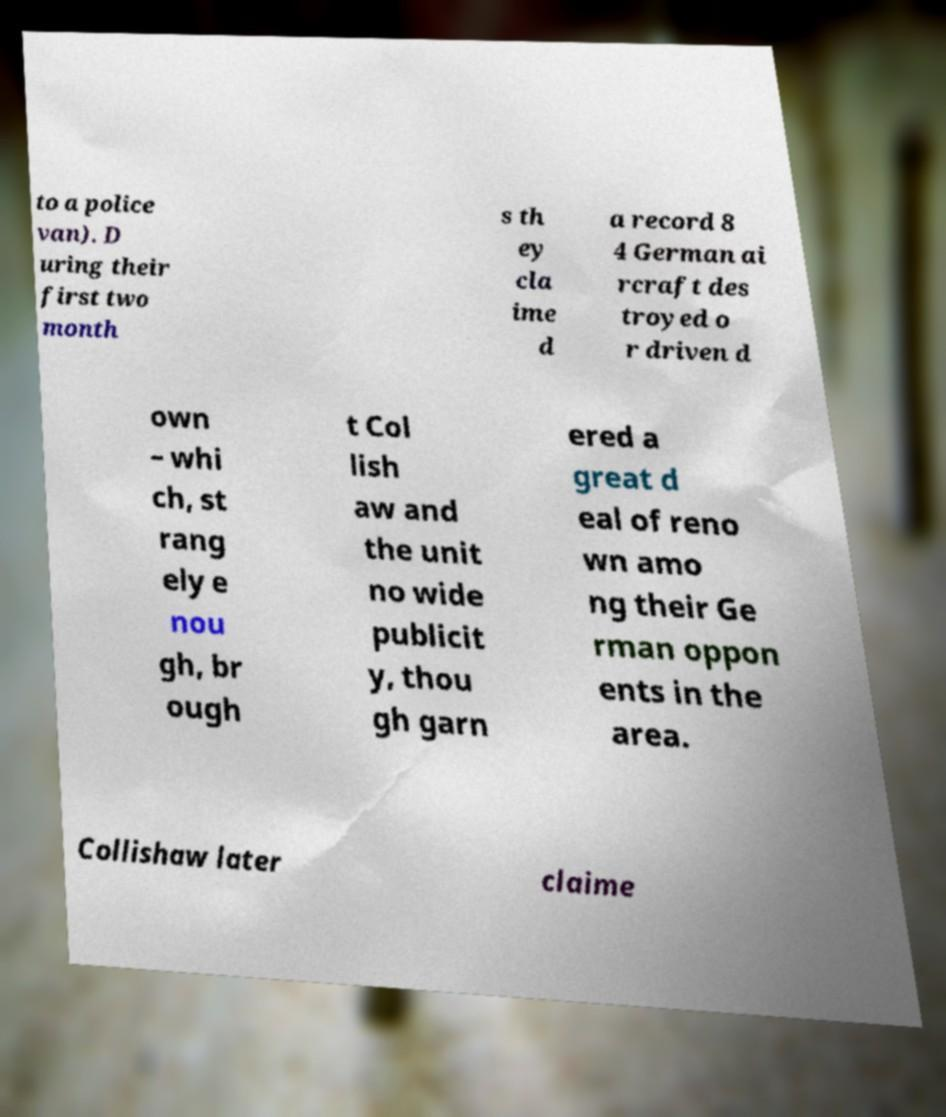Please read and relay the text visible in this image. What does it say? to a police van). D uring their first two month s th ey cla ime d a record 8 4 German ai rcraft des troyed o r driven d own – whi ch, st rang ely e nou gh, br ough t Col lish aw and the unit no wide publicit y, thou gh garn ered a great d eal of reno wn amo ng their Ge rman oppon ents in the area. Collishaw later claime 